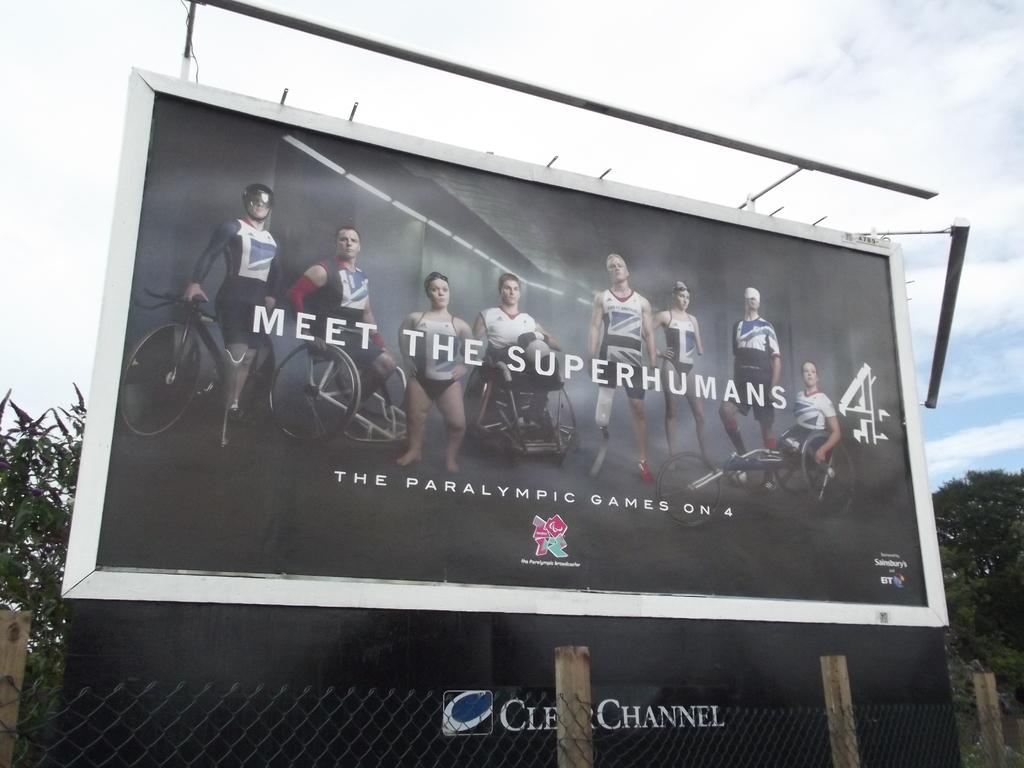Provide a one-sentence caption for the provided image. a billboard with Meet the Superhumans on it. 